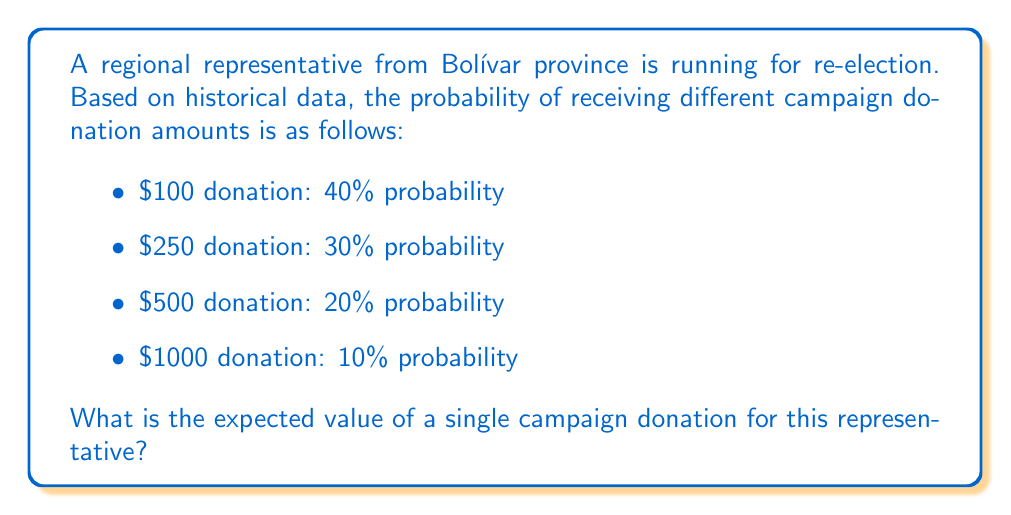Teach me how to tackle this problem. To calculate the expected value, we need to follow these steps:

1) The expected value is calculated by multiplying each possible outcome by its probability and then summing these products.

2) Let's define our formula:
   $$E(X) = \sum_{i=1}^{n} x_i \cdot p(x_i)$$
   Where $E(X)$ is the expected value, $x_i$ are the possible outcomes, and $p(x_i)$ are their respective probabilities.

3) Now, let's plug in our values:
   $$E(X) = 100 \cdot 0.40 + 250 \cdot 0.30 + 500 \cdot 0.20 + 1000 \cdot 0.10$$

4) Let's calculate each term:
   $$E(X) = 40 + 75 + 100 + 100$$

5) Sum up the results:
   $$E(X) = 315$$

Therefore, the expected value of a single campaign donation is $315.
Answer: $315 